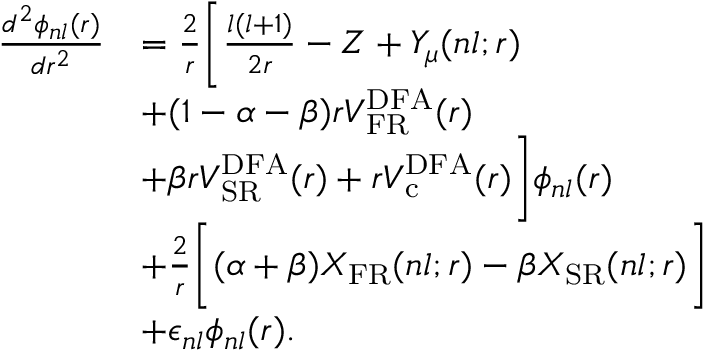Convert formula to latex. <formula><loc_0><loc_0><loc_500><loc_500>\begin{array} { r l } { \frac { d ^ { 2 } \phi _ { n l } ( r ) } { d r ^ { 2 } } } & { = \frac { 2 } { r } \left [ \frac { l ( l + 1 ) } { 2 r } - Z + Y _ { \mu } ( n l ; r ) } \\ & { + ( 1 - \alpha - \beta ) r V _ { F R } ^ { D F A } ( r ) } \\ & { + \beta r V _ { S R } ^ { D F A } ( r ) + r V _ { c } ^ { D F A } ( r ) \right ] \phi _ { n l } ( r ) } \\ & { + \frac { 2 } { r } \left [ ( \alpha + \beta ) X _ { F R } ( n l ; r ) - \beta X _ { S R } ( n l ; r ) \right ] } \\ & { + \epsilon _ { n l } \phi _ { n l } ( r ) . } \end{array}</formula> 